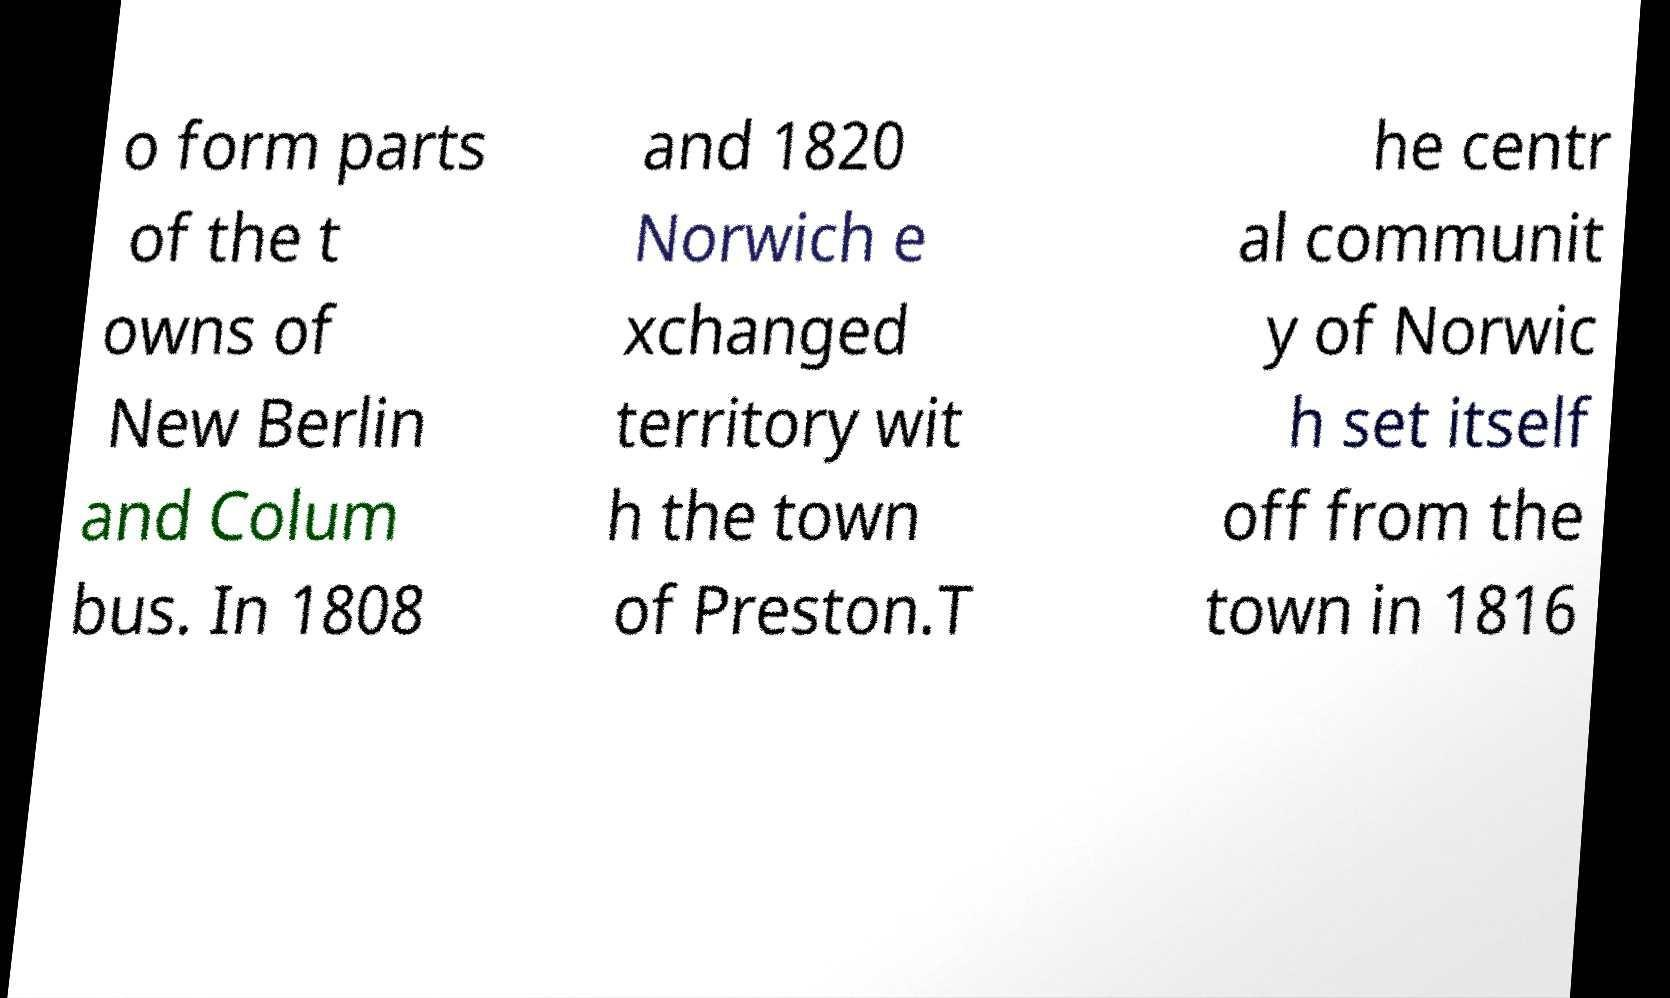Could you assist in decoding the text presented in this image and type it out clearly? o form parts of the t owns of New Berlin and Colum bus. In 1808 and 1820 Norwich e xchanged territory wit h the town of Preston.T he centr al communit y of Norwic h set itself off from the town in 1816 